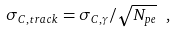<formula> <loc_0><loc_0><loc_500><loc_500>\sigma _ { C , t r a c k } = \sigma _ { C , \gamma } / \sqrt { N _ { p e } } \ ,</formula> 